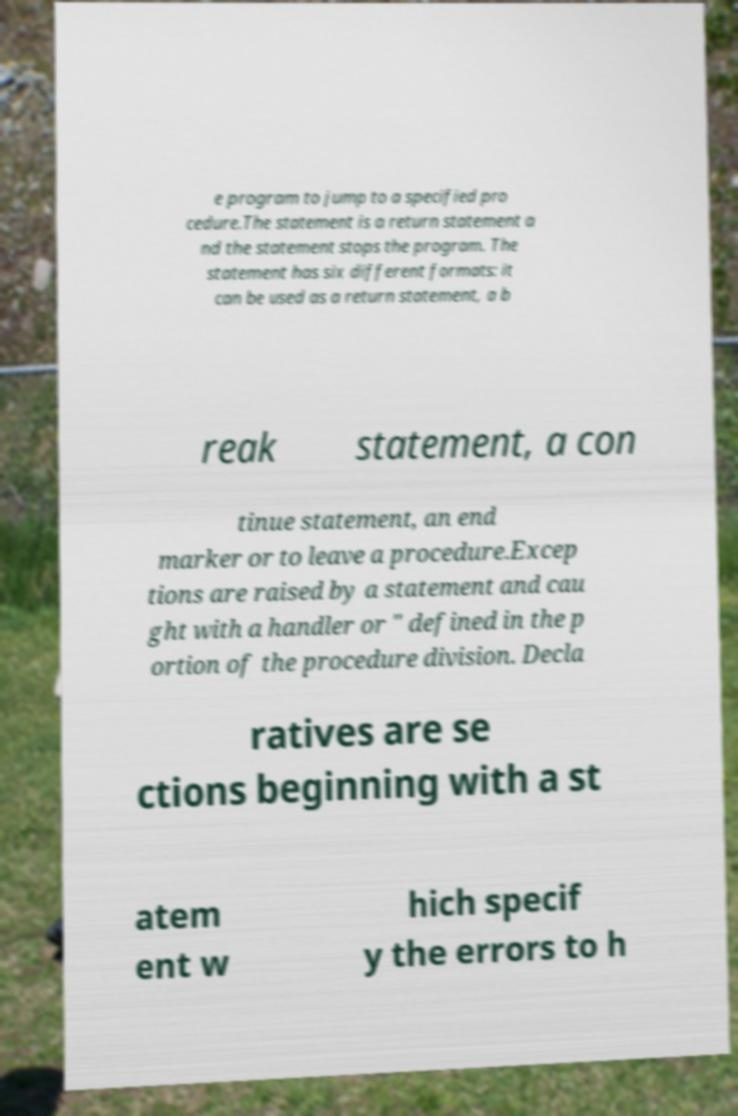Please read and relay the text visible in this image. What does it say? e program to jump to a specified pro cedure.The statement is a return statement a nd the statement stops the program. The statement has six different formats: it can be used as a return statement, a b reak statement, a con tinue statement, an end marker or to leave a procedure.Excep tions are raised by a statement and cau ght with a handler or " defined in the p ortion of the procedure division. Decla ratives are se ctions beginning with a st atem ent w hich specif y the errors to h 